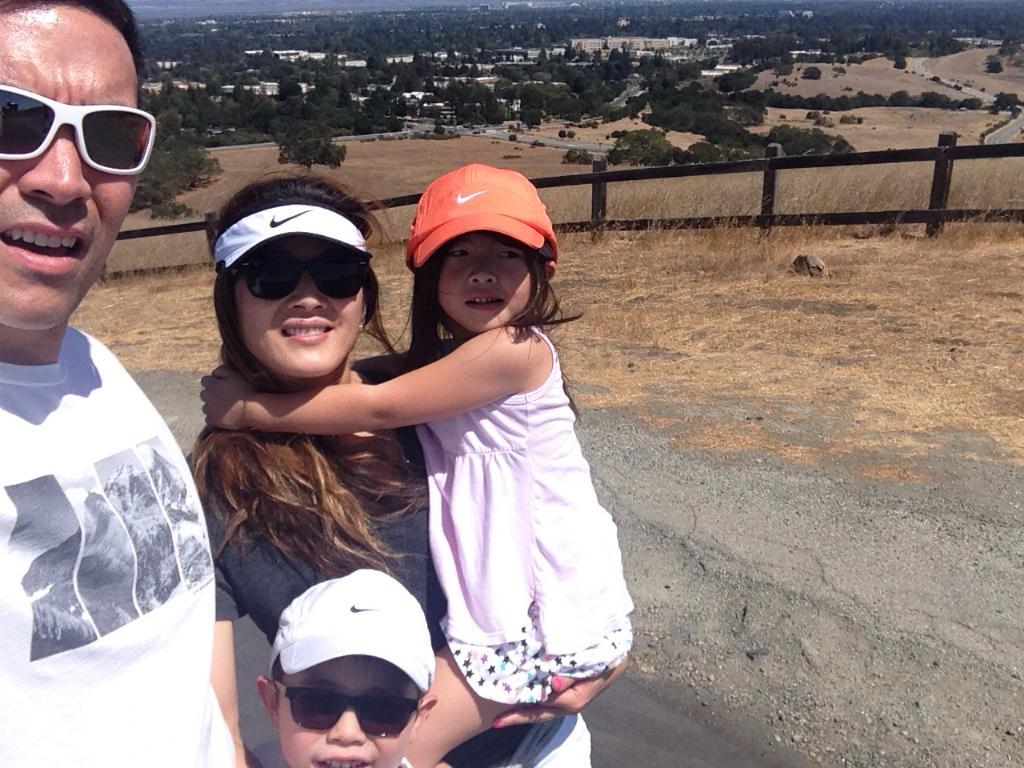Who is present in the image with the couple? The couple's children are present in the image. Where are the family members standing in the image? The family members are standing on a path. What can be seen in the background of the image? There is a wooden fence, trees, and buildings in the background of the image. What time of day is it in the image, and how does the mother feel? The time of day is not mentioned in the image, and there is no indication of the mother's feelings. 